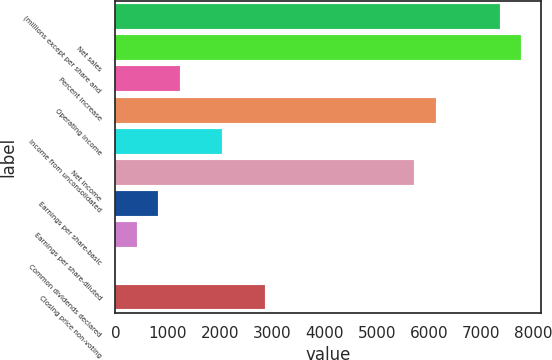Convert chart. <chart><loc_0><loc_0><loc_500><loc_500><bar_chart><fcel>(millions except per share and<fcel>Net sales<fcel>Percent increase<fcel>Operating income<fcel>Income from unconsolidated<fcel>Net income<fcel>Earnings per share-basic<fcel>Earnings per share-diluted<fcel>Common dividends declared<fcel>Closing price non-voting<nl><fcel>7357.14<fcel>7765.81<fcel>1227.14<fcel>6131.14<fcel>2044.47<fcel>5722.48<fcel>818.48<fcel>409.81<fcel>1.15<fcel>2861.8<nl></chart> 